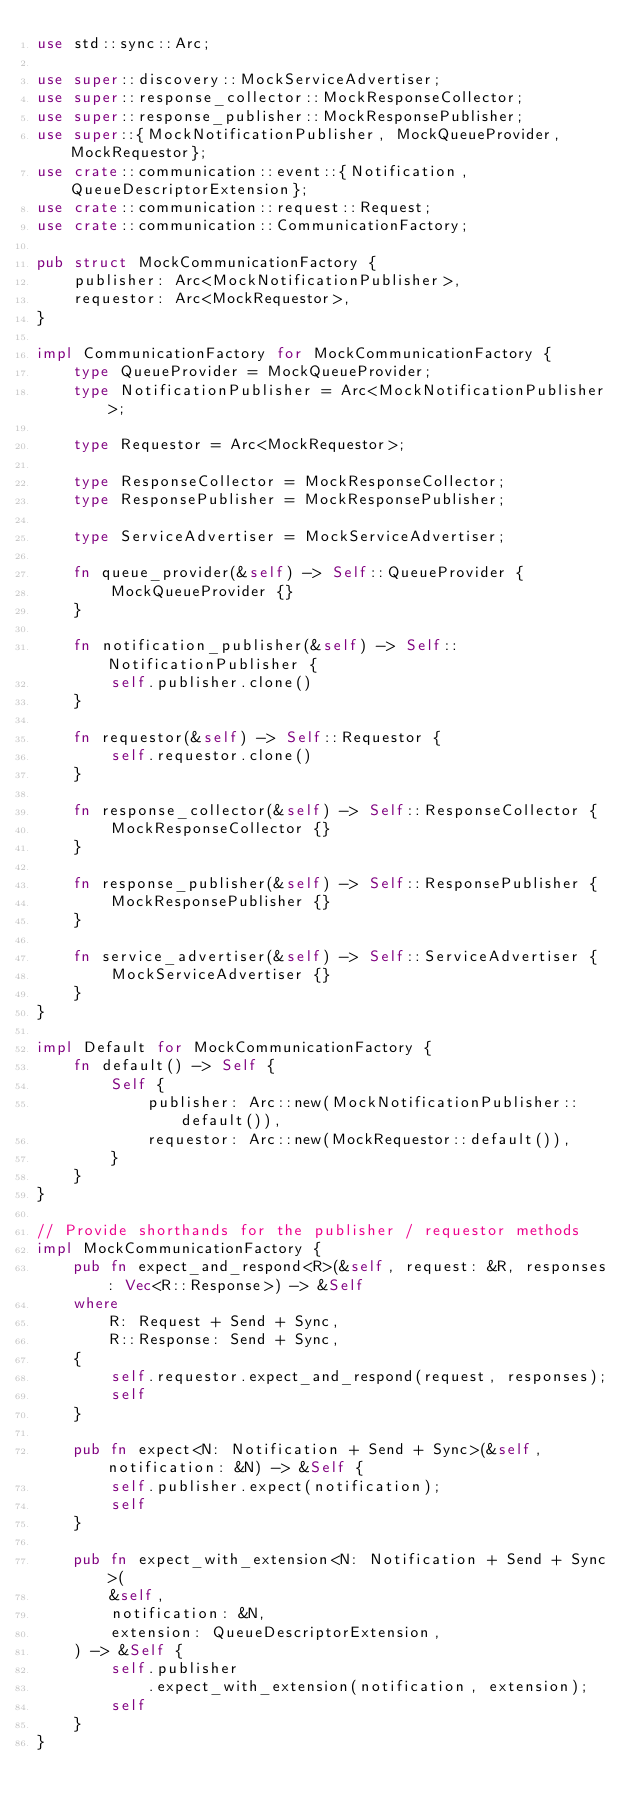<code> <loc_0><loc_0><loc_500><loc_500><_Rust_>use std::sync::Arc;

use super::discovery::MockServiceAdvertiser;
use super::response_collector::MockResponseCollector;
use super::response_publisher::MockResponsePublisher;
use super::{MockNotificationPublisher, MockQueueProvider, MockRequestor};
use crate::communication::event::{Notification, QueueDescriptorExtension};
use crate::communication::request::Request;
use crate::communication::CommunicationFactory;

pub struct MockCommunicationFactory {
    publisher: Arc<MockNotificationPublisher>,
    requestor: Arc<MockRequestor>,
}

impl CommunicationFactory for MockCommunicationFactory {
    type QueueProvider = MockQueueProvider;
    type NotificationPublisher = Arc<MockNotificationPublisher>;

    type Requestor = Arc<MockRequestor>;

    type ResponseCollector = MockResponseCollector;
    type ResponsePublisher = MockResponsePublisher;

    type ServiceAdvertiser = MockServiceAdvertiser;

    fn queue_provider(&self) -> Self::QueueProvider {
        MockQueueProvider {}
    }

    fn notification_publisher(&self) -> Self::NotificationPublisher {
        self.publisher.clone()
    }

    fn requestor(&self) -> Self::Requestor {
        self.requestor.clone()
    }

    fn response_collector(&self) -> Self::ResponseCollector {
        MockResponseCollector {}
    }

    fn response_publisher(&self) -> Self::ResponsePublisher {
        MockResponsePublisher {}
    }

    fn service_advertiser(&self) -> Self::ServiceAdvertiser {
        MockServiceAdvertiser {}
    }
}

impl Default for MockCommunicationFactory {
    fn default() -> Self {
        Self {
            publisher: Arc::new(MockNotificationPublisher::default()),
            requestor: Arc::new(MockRequestor::default()),
        }
    }
}

// Provide shorthands for the publisher / requestor methods
impl MockCommunicationFactory {
    pub fn expect_and_respond<R>(&self, request: &R, responses: Vec<R::Response>) -> &Self
    where
        R: Request + Send + Sync,
        R::Response: Send + Sync,
    {
        self.requestor.expect_and_respond(request, responses);
        self
    }

    pub fn expect<N: Notification + Send + Sync>(&self, notification: &N) -> &Self {
        self.publisher.expect(notification);
        self
    }

    pub fn expect_with_extension<N: Notification + Send + Sync>(
        &self,
        notification: &N,
        extension: QueueDescriptorExtension,
    ) -> &Self {
        self.publisher
            .expect_with_extension(notification, extension);
        self
    }
}
</code> 